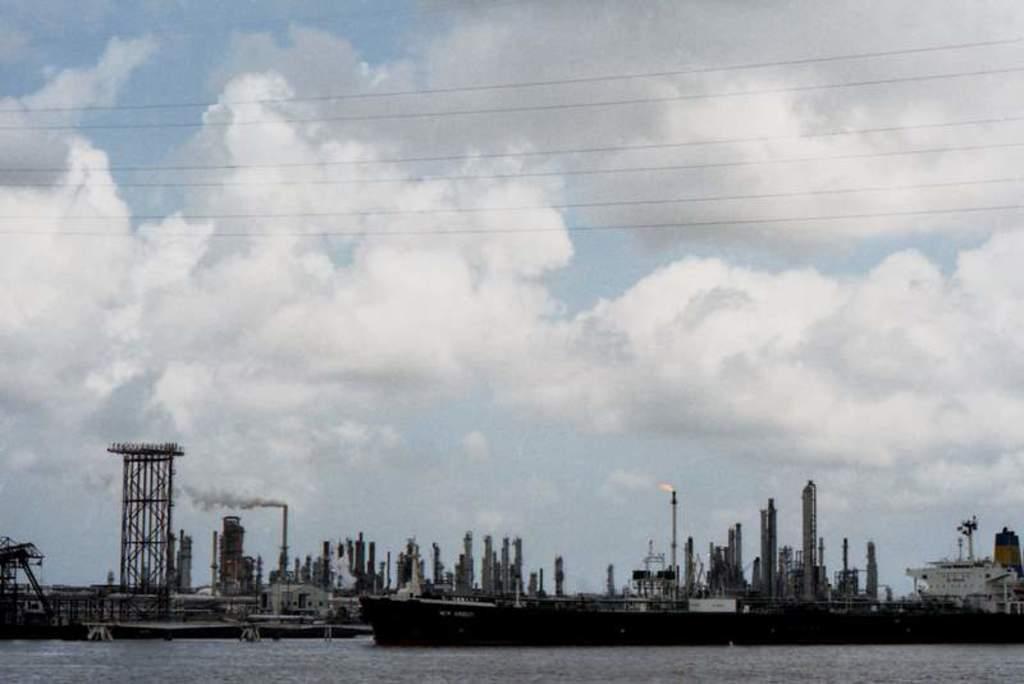In one or two sentences, can you explain what this image depicts? We can see ships above the water,smoke,fire and wires. In the background we can see sky with clouds. 